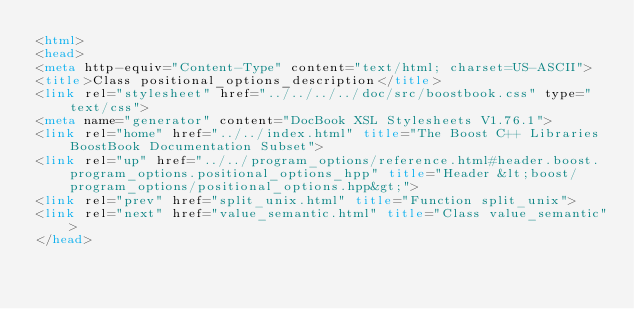<code> <loc_0><loc_0><loc_500><loc_500><_HTML_><html>
<head>
<meta http-equiv="Content-Type" content="text/html; charset=US-ASCII">
<title>Class positional_options_description</title>
<link rel="stylesheet" href="../../../../doc/src/boostbook.css" type="text/css">
<meta name="generator" content="DocBook XSL Stylesheets V1.76.1">
<link rel="home" href="../../index.html" title="The Boost C++ Libraries BoostBook Documentation Subset">
<link rel="up" href="../../program_options/reference.html#header.boost.program_options.positional_options_hpp" title="Header &lt;boost/program_options/positional_options.hpp&gt;">
<link rel="prev" href="split_unix.html" title="Function split_unix">
<link rel="next" href="value_semantic.html" title="Class value_semantic">
</head></code> 